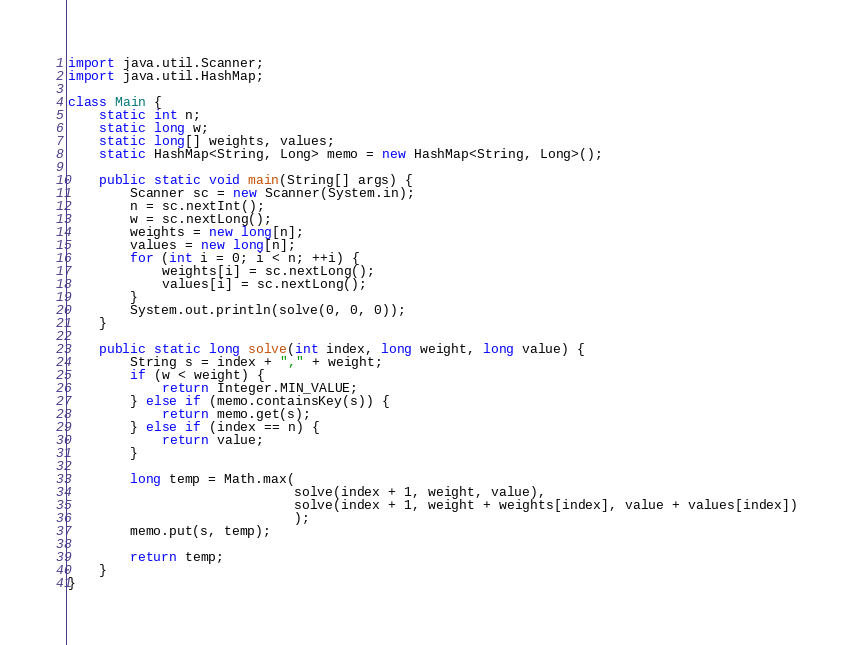Convert code to text. <code><loc_0><loc_0><loc_500><loc_500><_Java_>import java.util.Scanner;
import java.util.HashMap;

class Main {
    static int n;
    static long w;
    static long[] weights, values;
    static HashMap<String, Long> memo = new HashMap<String, Long>();

    public static void main(String[] args) {
        Scanner sc = new Scanner(System.in);
        n = sc.nextInt();
        w = sc.nextLong();
        weights = new long[n];
        values = new long[n];
        for (int i = 0; i < n; ++i) {
            weights[i] = sc.nextLong();
            values[i] = sc.nextLong();
        }
        System.out.println(solve(0, 0, 0));
    }

    public static long solve(int index, long weight, long value) {
        String s = index + "," + weight;
        if (w < weight) {
            return Integer.MIN_VALUE;
        } else if (memo.containsKey(s)) {
            return memo.get(s);
        } else if (index == n) {
            return value;
        } 
        
        long temp = Math.max(
                             solve(index + 1, weight, value),
                             solve(index + 1, weight + weights[index], value + values[index])
                             );
        memo.put(s, temp);
        
        return temp;
    }
}
</code> 